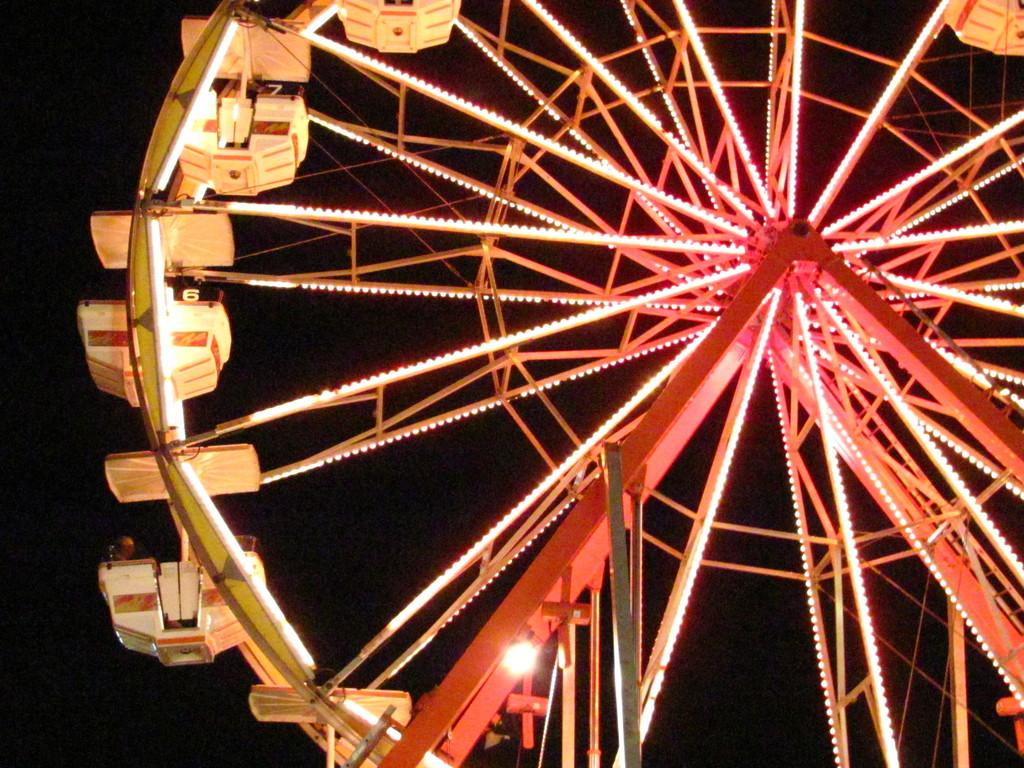What is located in the foreground of the image? In the foreground of the image, there is a wheel, metal rods, and lights. What is the nature of the lights in the image? The lights in the image are likely to be illuminated. What can be seen in the background of the image? Sky is visible in the background of the image. What time of day might the image have been taken? The image is likely taken during night, as the lights are illuminated and the sky is visible. What type of lace can be seen on the wheel in the image? There is no lace present on the wheel in the image. Is there a heart-shaped object visible in the image? There is no heart-shaped object visible in the image. 